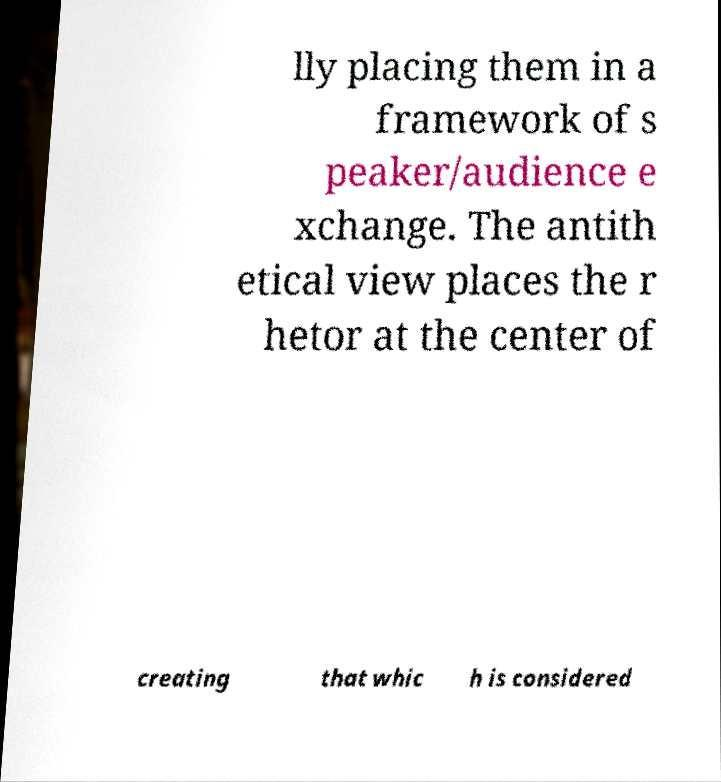For documentation purposes, I need the text within this image transcribed. Could you provide that? lly placing them in a framework of s peaker/audience e xchange. The antith etical view places the r hetor at the center of creating that whic h is considered 